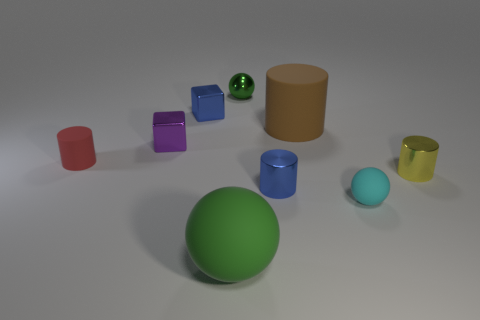Is there any other thing that is the same shape as the small green thing?
Make the answer very short. Yes. There is a matte cylinder right of the red rubber object; how big is it?
Provide a succinct answer. Large. How many other objects are the same color as the large cylinder?
Offer a very short reply. 0. The cylinder that is on the left side of the small blue metallic object behind the tiny red cylinder is made of what material?
Provide a short and direct response. Rubber. Is the color of the big rubber object on the left side of the green metal sphere the same as the tiny rubber cylinder?
Keep it short and to the point. No. How many green things are the same shape as the yellow thing?
Your answer should be very brief. 0. What size is the brown thing that is the same material as the small red cylinder?
Your answer should be compact. Large. Is there a sphere in front of the small cylinder that is on the left side of the green ball that is in front of the yellow shiny object?
Your answer should be very brief. Yes. There is a green ball that is on the right side of the green rubber sphere; does it have the same size as the red rubber thing?
Your response must be concise. Yes. What number of red things have the same size as the cyan rubber object?
Offer a terse response. 1. 